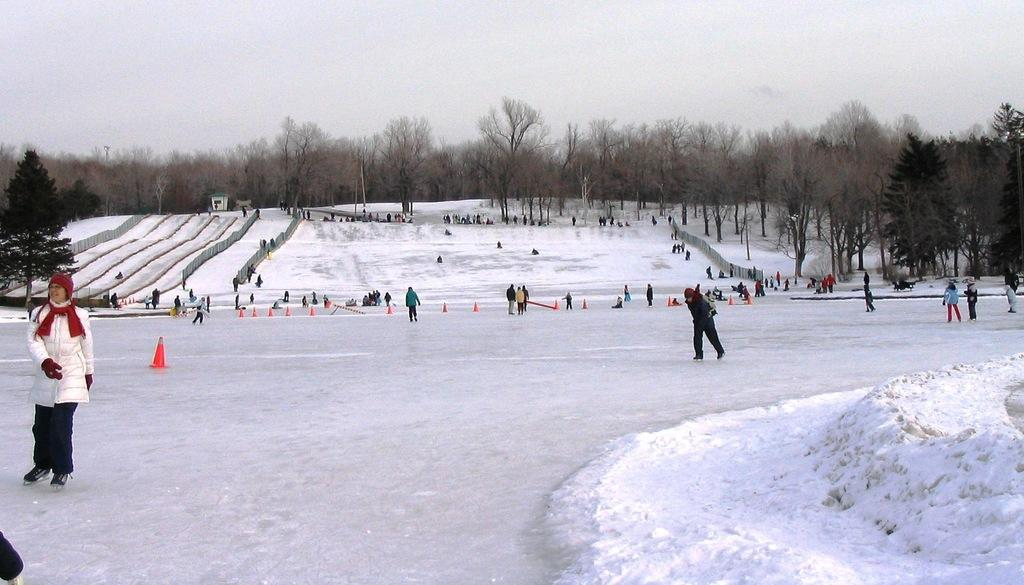What are the persons in the image doing? The persons in the image are skating. On what surface are they skating? They are skating on snow. What can be seen in the background of the image? There are trees in the background of the image. How would you describe the weather based on the sky in the image? The sky is cloudy in the image, suggesting a potentially overcast or snowy day. What type of sound can be heard coming from the rabbit in the image? There is no rabbit present in the image, so it is not possible to determine any sounds coming from it. 